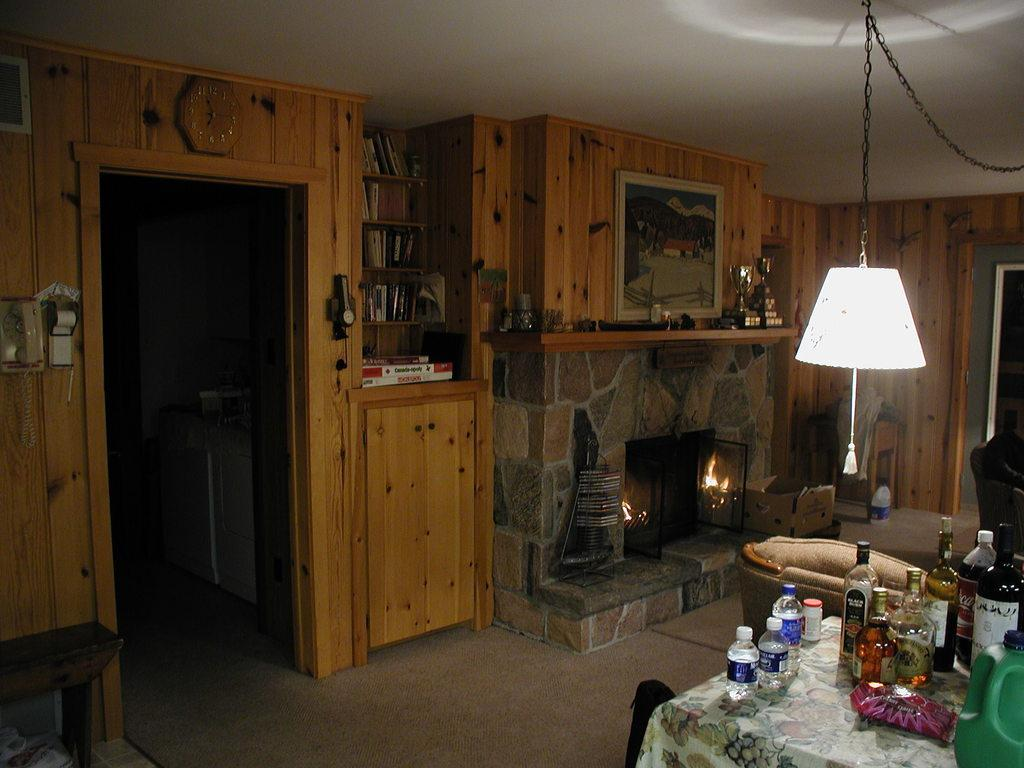What type of bottles are in the image? There are wine bottles and glass bottles in the image. Where are the bottles located? The bottles are on a table. What is the material of the background in the image? The background is made of wood. What can be seen in the image that might be used for heating or cooking? There is a fire burner in the image. What type of design can be seen on the bushes in the image? There are no bushes present in the image. What tool might be used to hammer nails in the image? There is no hammer or any indication of a need for hammering in the image. 